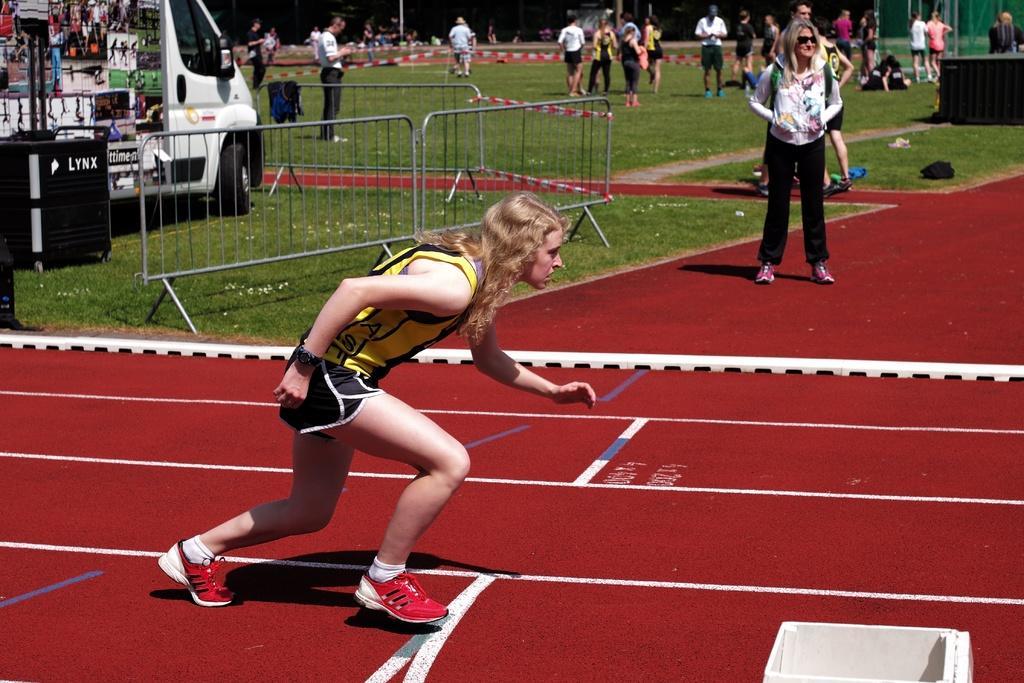Please provide a concise description of this image. In this picture I can observe a woman running on the running track. In the middle of the picture I can observe a railing. On the left side there is a vehicle on the ground. In the background there are some people walking on the ground. 